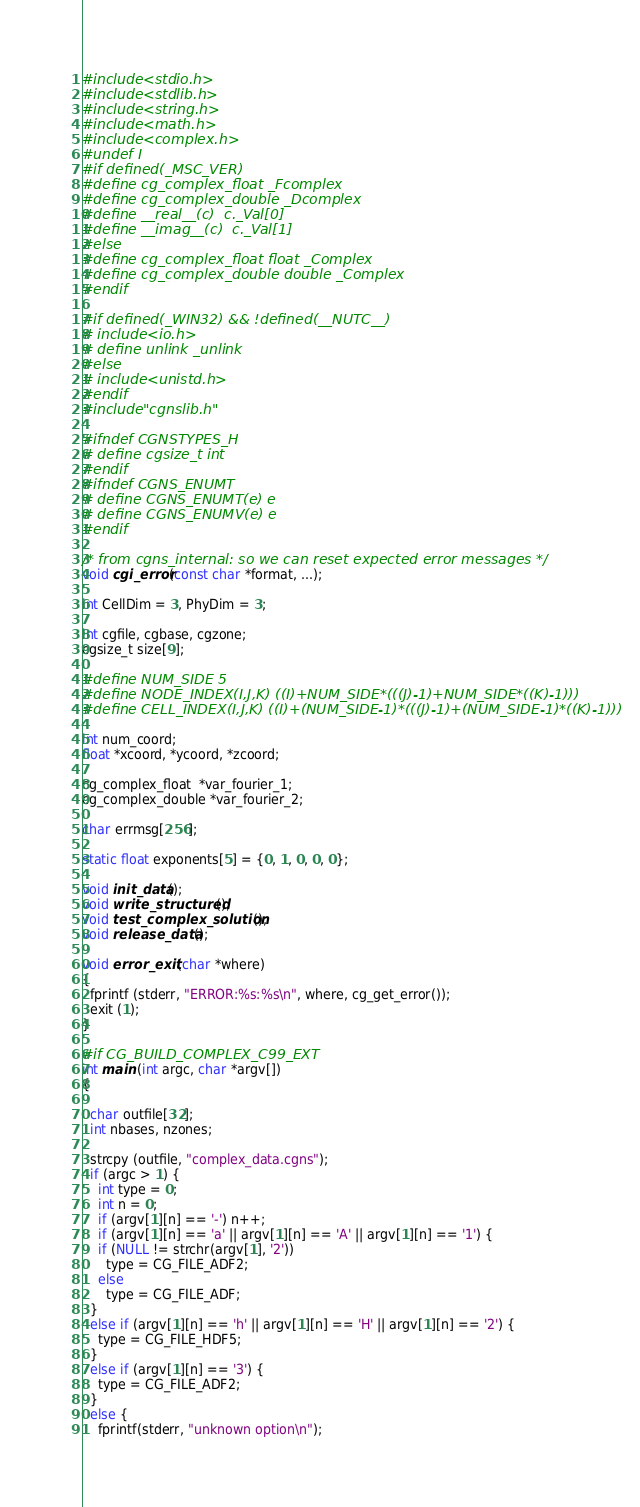<code> <loc_0><loc_0><loc_500><loc_500><_C_>#include <stdio.h>
#include <stdlib.h>
#include <string.h>
#include <math.h>
#include <complex.h>
#undef I
#if defined(_MSC_VER)
#define cg_complex_float _Fcomplex
#define cg_complex_double _Dcomplex
#define __real__(c)  c._Val[0]
#define __imag__(c)  c._Val[1]
#else
#define cg_complex_float float _Complex
#define cg_complex_double double _Complex
#endif

#if defined(_WIN32) && !defined(__NUTC__)
# include <io.h>
# define unlink _unlink
#else
# include <unistd.h>
#endif
#include "cgnslib.h"

#ifndef CGNSTYPES_H
# define cgsize_t int
#endif
#ifndef CGNS_ENUMT
# define CGNS_ENUMT(e) e
# define CGNS_ENUMV(e) e
#endif

/* from cgns_internal: so we can reset expected error messages */
void cgi_error(const char *format, ...);

int CellDim = 3, PhyDim = 3;

int cgfile, cgbase, cgzone;
cgsize_t size[9];

#define NUM_SIDE 5
#define NODE_INDEX(I,J,K) ((I)+NUM_SIDE*(((J)-1)+NUM_SIDE*((K)-1)))
#define CELL_INDEX(I,J,K) ((I)+(NUM_SIDE-1)*(((J)-1)+(NUM_SIDE-1)*((K)-1)))

int num_coord;
float *xcoord, *ycoord, *zcoord;

cg_complex_float  *var_fourier_1;
cg_complex_double *var_fourier_2;

char errmsg[256];

static float exponents[5] = {0, 1, 0, 0, 0};

void init_data();
void write_structured();
void test_complex_solution();
void release_data();

void error_exit (char *where)
{
  fprintf (stderr, "ERROR:%s:%s\n", where, cg_get_error());
  exit (1);
}

#if CG_BUILD_COMPLEX_C99_EXT
int main (int argc, char *argv[])
{

  char outfile[32];
  int nbases, nzones;

  strcpy (outfile, "complex_data.cgns");
  if (argc > 1) {
    int type = 0;
    int n = 0;
    if (argv[1][n] == '-') n++;
    if (argv[1][n] == 'a' || argv[1][n] == 'A' || argv[1][n] == '1') {
    if (NULL != strchr(argv[1], '2'))
      type = CG_FILE_ADF2;
    else
      type = CG_FILE_ADF;
  }
  else if (argv[1][n] == 'h' || argv[1][n] == 'H' || argv[1][n] == '2') {
    type = CG_FILE_HDF5;
  }
  else if (argv[1][n] == '3') {
    type = CG_FILE_ADF2;
  }
  else {
    fprintf(stderr, "unknown option\n");</code> 